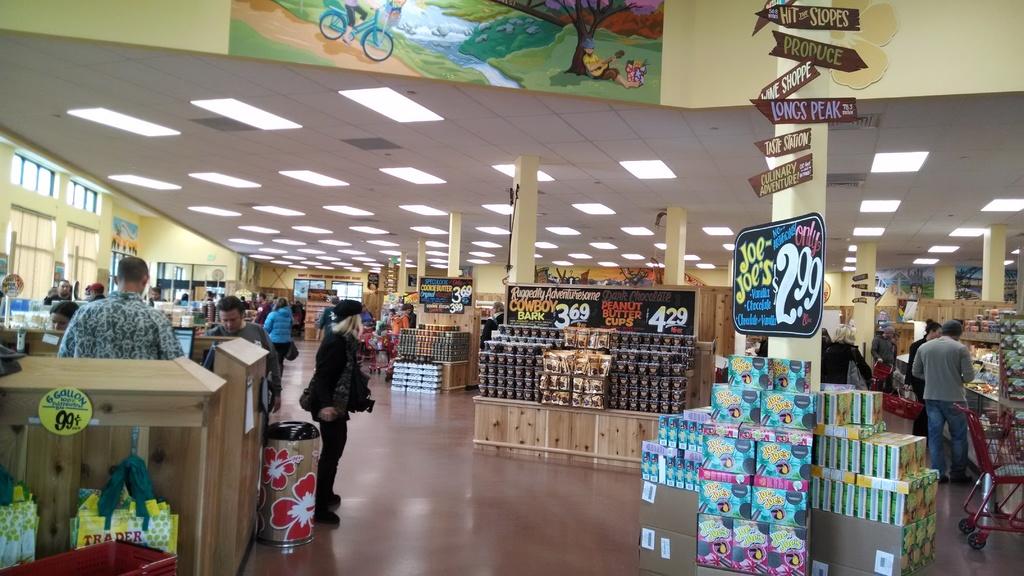How much are peanut butter cups?
Offer a terse response. 4.29. 